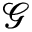Convert formula to latex. <formula><loc_0><loc_0><loc_500><loc_500>\mathcal { G }</formula> 